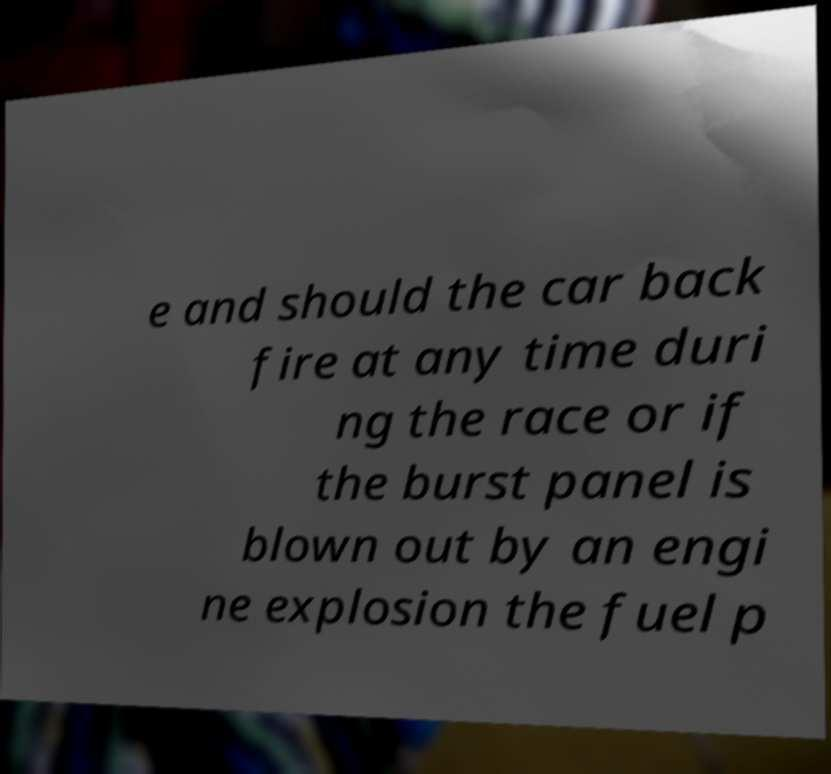Please identify and transcribe the text found in this image. e and should the car back fire at any time duri ng the race or if the burst panel is blown out by an engi ne explosion the fuel p 